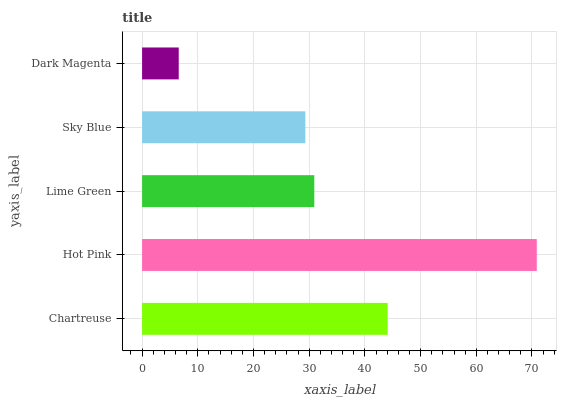Is Dark Magenta the minimum?
Answer yes or no. Yes. Is Hot Pink the maximum?
Answer yes or no. Yes. Is Lime Green the minimum?
Answer yes or no. No. Is Lime Green the maximum?
Answer yes or no. No. Is Hot Pink greater than Lime Green?
Answer yes or no. Yes. Is Lime Green less than Hot Pink?
Answer yes or no. Yes. Is Lime Green greater than Hot Pink?
Answer yes or no. No. Is Hot Pink less than Lime Green?
Answer yes or no. No. Is Lime Green the high median?
Answer yes or no. Yes. Is Lime Green the low median?
Answer yes or no. Yes. Is Chartreuse the high median?
Answer yes or no. No. Is Chartreuse the low median?
Answer yes or no. No. 